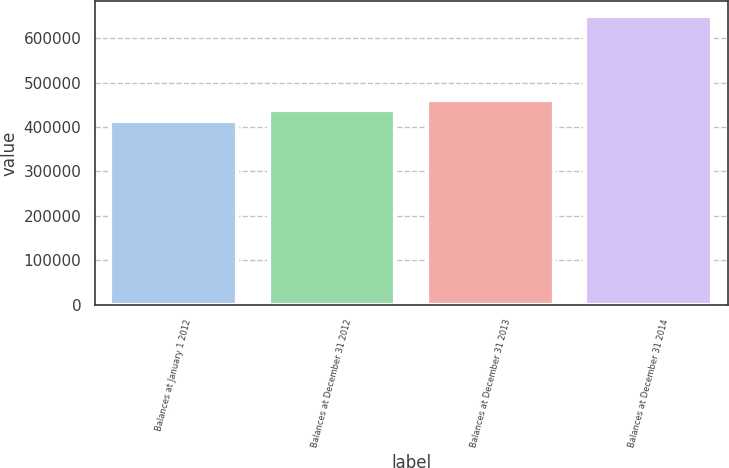<chart> <loc_0><loc_0><loc_500><loc_500><bar_chart><fcel>Balances at January 1 2012<fcel>Balances at December 31 2012<fcel>Balances at December 31 2013<fcel>Balances at December 31 2014<nl><fcel>413704<fcel>437311<fcel>460919<fcel>649778<nl></chart> 